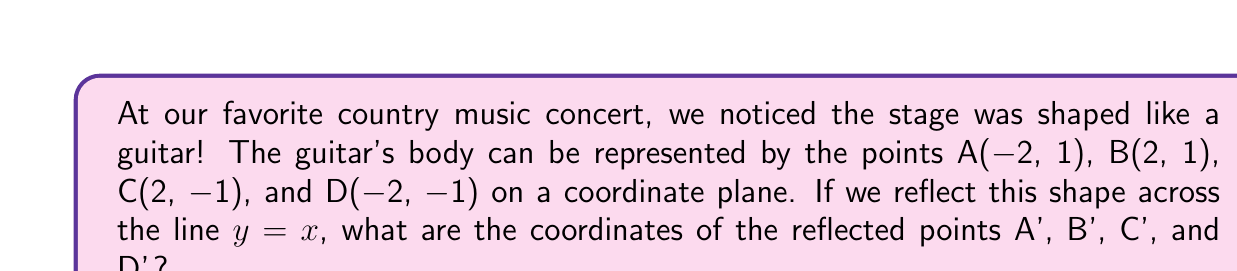Give your solution to this math problem. Let's approach this step-by-step:

1) To reflect a point (x, y) across the line y = x, we swap the x and y coordinates. So (x, y) becomes (y, x).

2) For point A(-2, 1):
   A(-2, 1) becomes A'(1, -2)

3) For point B(2, 1):
   B(2, 1) becomes B'(1, 2)

4) For point C(2, -1):
   C(2, -1) becomes C'(-1, 2)

5) For point D(-2, -1):
   D(-2, -1) becomes D'(-1, -2)

We can verify this visually:

[asy]
import geometry;

unitsize(1cm);

draw((-3,-3)--(3,3), dashed);
label("y = x", (2.5,2.5), NE);

draw((-2,1)--(2,1)--(2,-1)--(-2,-1)--cycle, blue);
draw((1,-2)--(1,2)--(-1,2)--(-1,-2)--cycle, red);

dot((-2,1)); label("A", (-2,1), NW);
dot((2,1)); label("B", (2,1), NE);
dot((2,-1)); label("C", (2,-1), SE);
dot((-2,-1)); label("D", (-2,-1), SW);

dot((1,-2)); label("A'", (1,-2), SE);
dot((1,2)); label("B'", (1,2), NE);
dot((-1,2)); label("C'", (-1,2), NW);
dot((-1,-2)); label("D'", (-1,-2), SW);
[/asy]

The blue shape represents the original guitar, and the red shape is its reflection across y = x.
Answer: A'(1, -2), B'(1, 2), C'(-1, 2), D'(-1, -2) 